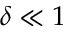<formula> <loc_0><loc_0><loc_500><loc_500>\delta \ll 1</formula> 